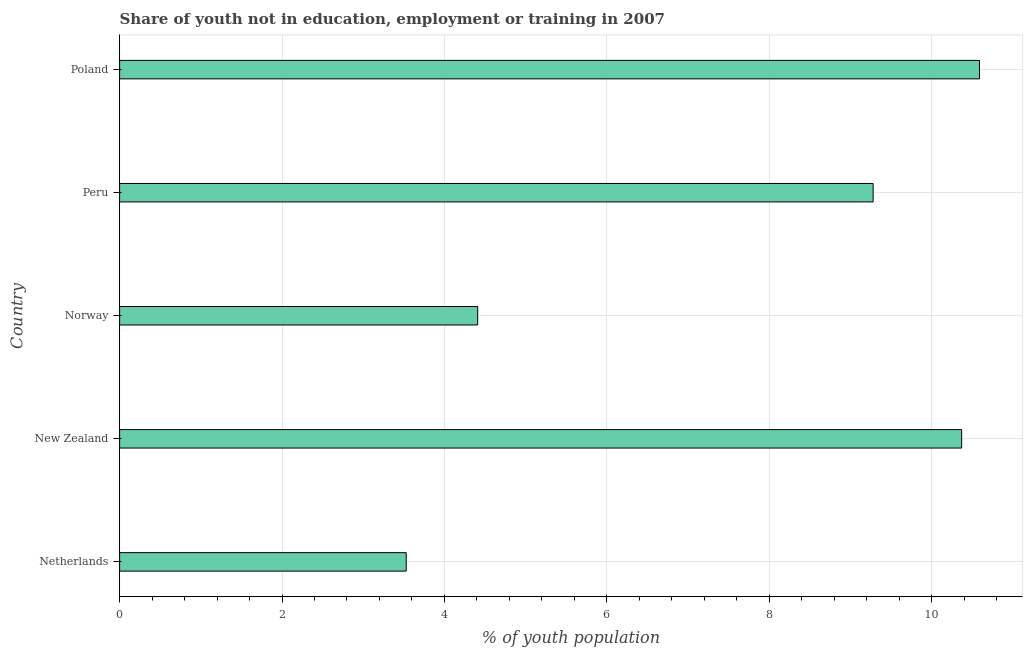Does the graph contain grids?
Provide a short and direct response. Yes. What is the title of the graph?
Your answer should be very brief. Share of youth not in education, employment or training in 2007. What is the label or title of the X-axis?
Your response must be concise. % of youth population. What is the unemployed youth population in Norway?
Give a very brief answer. 4.41. Across all countries, what is the maximum unemployed youth population?
Provide a short and direct response. 10.59. Across all countries, what is the minimum unemployed youth population?
Give a very brief answer. 3.53. What is the sum of the unemployed youth population?
Provide a succinct answer. 38.18. What is the difference between the unemployed youth population in Netherlands and Peru?
Ensure brevity in your answer.  -5.75. What is the average unemployed youth population per country?
Make the answer very short. 7.64. What is the median unemployed youth population?
Give a very brief answer. 9.28. What is the ratio of the unemployed youth population in New Zealand to that in Poland?
Ensure brevity in your answer.  0.98. Is the unemployed youth population in Norway less than that in Poland?
Ensure brevity in your answer.  Yes. Is the difference between the unemployed youth population in Netherlands and Norway greater than the difference between any two countries?
Offer a very short reply. No. What is the difference between the highest and the second highest unemployed youth population?
Keep it short and to the point. 0.22. Is the sum of the unemployed youth population in Norway and Peru greater than the maximum unemployed youth population across all countries?
Give a very brief answer. Yes. What is the difference between the highest and the lowest unemployed youth population?
Your answer should be very brief. 7.06. How many bars are there?
Provide a short and direct response. 5. What is the % of youth population in Netherlands?
Your answer should be compact. 3.53. What is the % of youth population of New Zealand?
Ensure brevity in your answer.  10.37. What is the % of youth population in Norway?
Keep it short and to the point. 4.41. What is the % of youth population of Peru?
Provide a short and direct response. 9.28. What is the % of youth population of Poland?
Your response must be concise. 10.59. What is the difference between the % of youth population in Netherlands and New Zealand?
Your answer should be very brief. -6.84. What is the difference between the % of youth population in Netherlands and Norway?
Keep it short and to the point. -0.88. What is the difference between the % of youth population in Netherlands and Peru?
Your response must be concise. -5.75. What is the difference between the % of youth population in Netherlands and Poland?
Keep it short and to the point. -7.06. What is the difference between the % of youth population in New Zealand and Norway?
Keep it short and to the point. 5.96. What is the difference between the % of youth population in New Zealand and Peru?
Give a very brief answer. 1.09. What is the difference between the % of youth population in New Zealand and Poland?
Keep it short and to the point. -0.22. What is the difference between the % of youth population in Norway and Peru?
Ensure brevity in your answer.  -4.87. What is the difference between the % of youth population in Norway and Poland?
Keep it short and to the point. -6.18. What is the difference between the % of youth population in Peru and Poland?
Your response must be concise. -1.31. What is the ratio of the % of youth population in Netherlands to that in New Zealand?
Offer a very short reply. 0.34. What is the ratio of the % of youth population in Netherlands to that in Norway?
Your answer should be very brief. 0.8. What is the ratio of the % of youth population in Netherlands to that in Peru?
Provide a short and direct response. 0.38. What is the ratio of the % of youth population in Netherlands to that in Poland?
Your answer should be compact. 0.33. What is the ratio of the % of youth population in New Zealand to that in Norway?
Ensure brevity in your answer.  2.35. What is the ratio of the % of youth population in New Zealand to that in Peru?
Give a very brief answer. 1.12. What is the ratio of the % of youth population in Norway to that in Peru?
Provide a short and direct response. 0.47. What is the ratio of the % of youth population in Norway to that in Poland?
Your answer should be very brief. 0.42. What is the ratio of the % of youth population in Peru to that in Poland?
Keep it short and to the point. 0.88. 